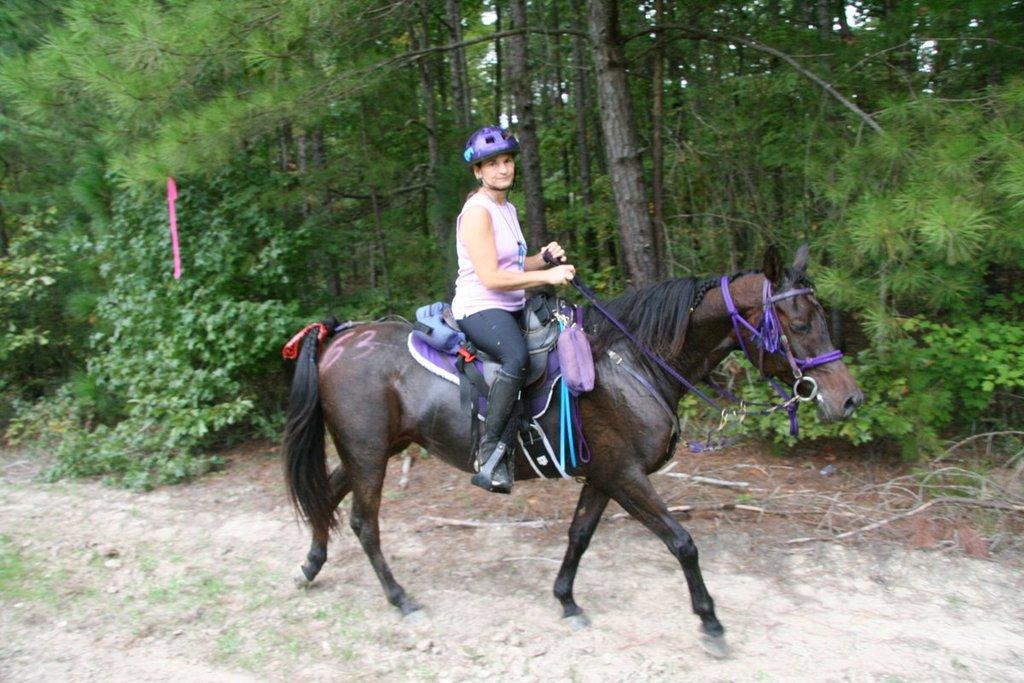What is the main subject of the image? There is a person riding a horse in the image. What can be seen beneath the horse and rider? The ground is visible in the image. What type of vegetation is present in the image? There is grass, plants, and trees in the image. Where is the market located in the image? There is no market present in the image. What type of prison can be seen in the image? There is no prison present in the image. 